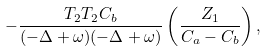Convert formula to latex. <formula><loc_0><loc_0><loc_500><loc_500>- \frac { T _ { 2 } T _ { 2 } C _ { b } } { ( - \Delta + \omega ) ( - \Delta + \omega ) } \left ( \frac { Z _ { 1 } } { C _ { a } - C _ { b } } \right ) ,</formula> 